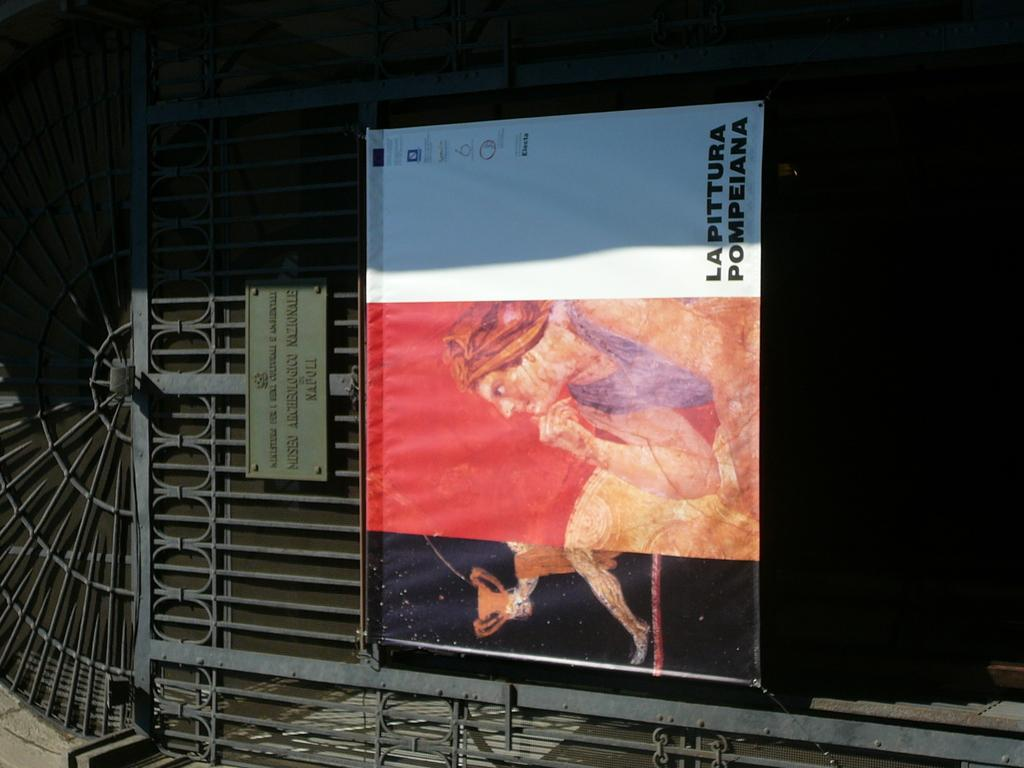<image>
Present a compact description of the photo's key features. A sign for lapittura pompeiana partially in the sun 